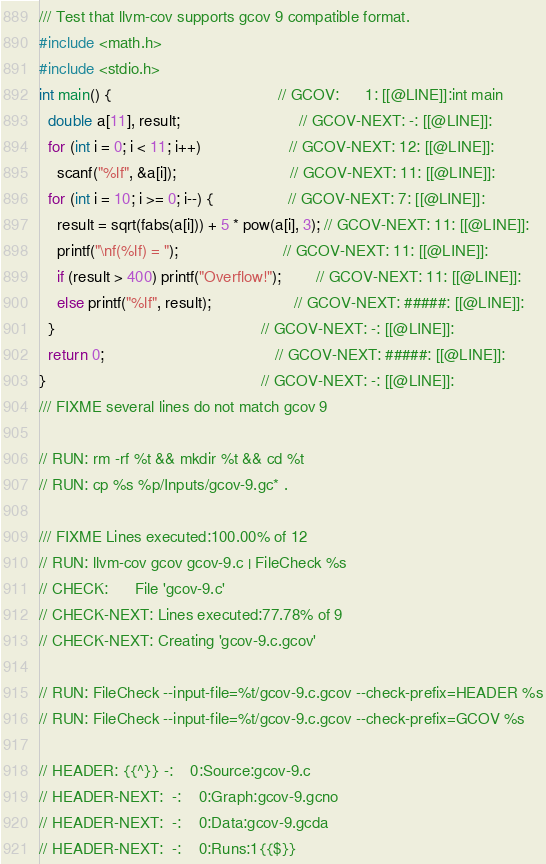Convert code to text. <code><loc_0><loc_0><loc_500><loc_500><_C_>/// Test that llvm-cov supports gcov 9 compatible format.
#include <math.h>
#include <stdio.h>
int main() {                                      // GCOV:      1: [[@LINE]]:int main
  double a[11], result;                           // GCOV-NEXT: -: [[@LINE]]:
  for (int i = 0; i < 11; i++)                    // GCOV-NEXT: 12: [[@LINE]]:
    scanf("%lf", &a[i]);                          // GCOV-NEXT: 11: [[@LINE]]:
  for (int i = 10; i >= 0; i--) {                 // GCOV-NEXT: 7: [[@LINE]]:
    result = sqrt(fabs(a[i])) + 5 * pow(a[i], 3); // GCOV-NEXT: 11: [[@LINE]]:
    printf("\nf(%lf) = ");                        // GCOV-NEXT: 11: [[@LINE]]:
    if (result > 400) printf("Overflow!");        // GCOV-NEXT: 11: [[@LINE]]:
    else printf("%lf", result);                   // GCOV-NEXT: #####: [[@LINE]]:
  }                                               // GCOV-NEXT: -: [[@LINE]]:
  return 0;                                       // GCOV-NEXT: #####: [[@LINE]]:
}                                                 // GCOV-NEXT: -: [[@LINE]]:
/// FIXME several lines do not match gcov 9

// RUN: rm -rf %t && mkdir %t && cd %t
// RUN: cp %s %p/Inputs/gcov-9.gc* .

/// FIXME Lines executed:100.00% of 12
// RUN: llvm-cov gcov gcov-9.c | FileCheck %s
// CHECK:      File 'gcov-9.c'
// CHECK-NEXT: Lines executed:77.78% of 9
// CHECK-NEXT: Creating 'gcov-9.c.gcov'

// RUN: FileCheck --input-file=%t/gcov-9.c.gcov --check-prefix=HEADER %s
// RUN: FileCheck --input-file=%t/gcov-9.c.gcov --check-prefix=GCOV %s

// HEADER: {{^}} -:    0:Source:gcov-9.c
// HEADER-NEXT:  -:    0:Graph:gcov-9.gcno
// HEADER-NEXT:  -:    0:Data:gcov-9.gcda
// HEADER-NEXT:  -:    0:Runs:1{{$}}</code> 